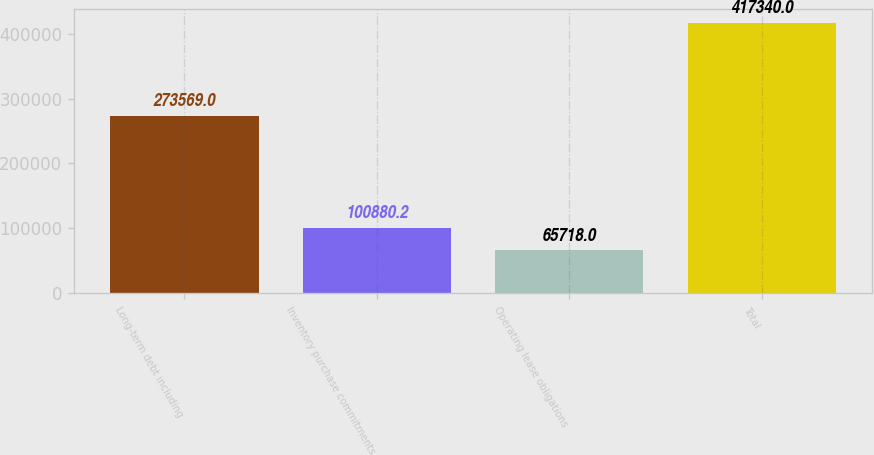Convert chart. <chart><loc_0><loc_0><loc_500><loc_500><bar_chart><fcel>Long-term debt including<fcel>Inventory purchase commitments<fcel>Operating lease obligations<fcel>Total<nl><fcel>273569<fcel>100880<fcel>65718<fcel>417340<nl></chart> 